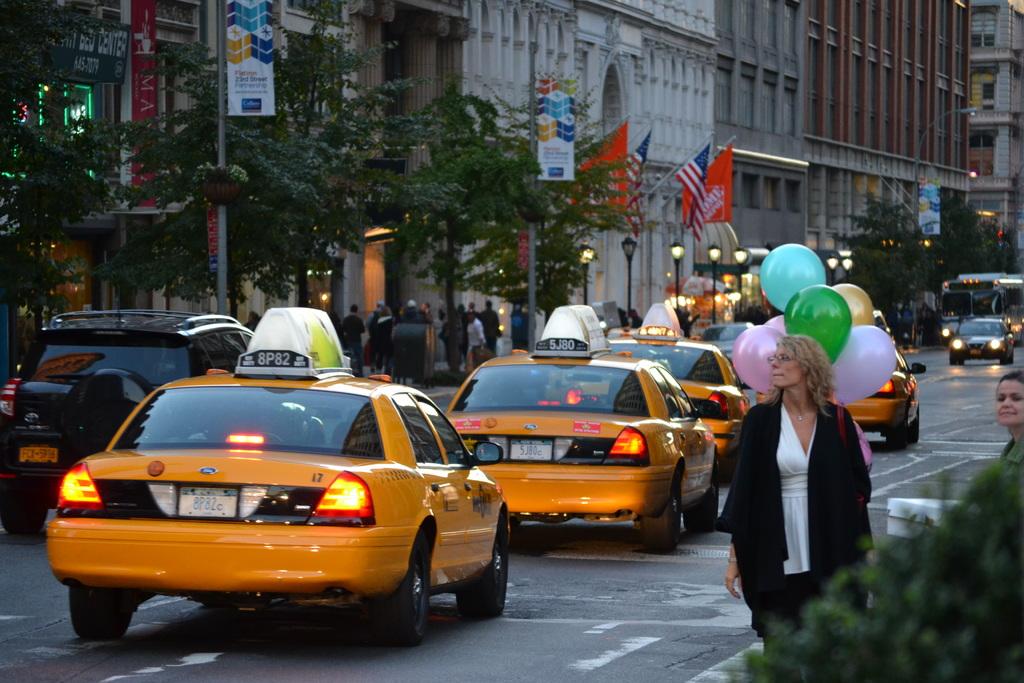What is the license plate on the taxi at back of the line?
Make the answer very short. Unanswerable. What is the plate of the taxi in front of the last one?
Your answer should be very brief. 5j80c. 